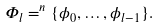<formula> <loc_0><loc_0><loc_500><loc_500>\Phi _ { l } = ^ { n } \{ \phi _ { 0 } , \dots , \phi _ { l - 1 } \} .</formula> 